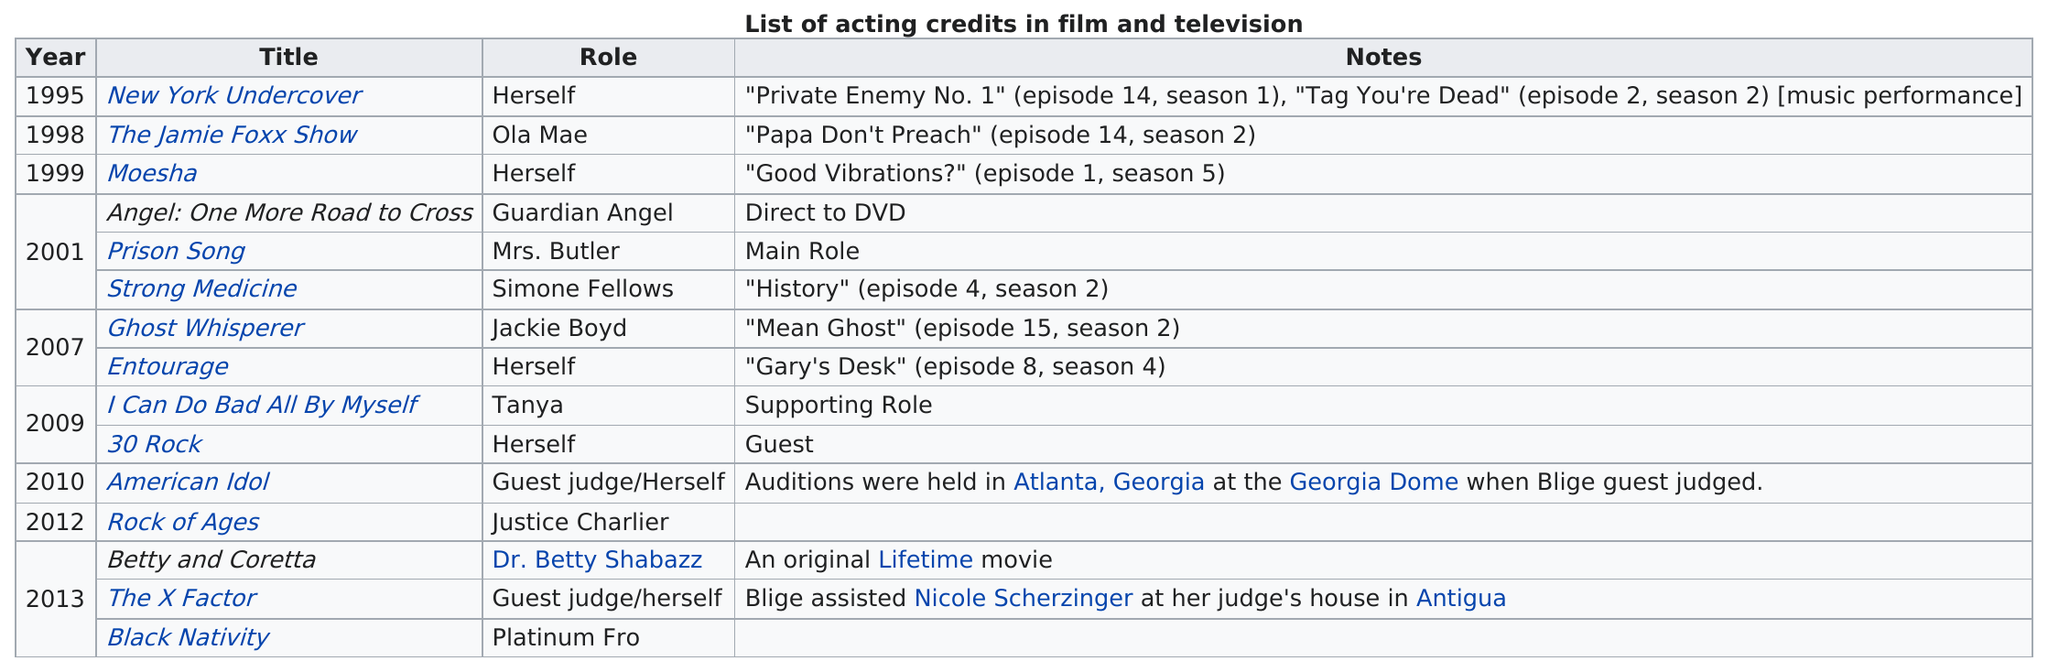Specify some key components in this picture. She has played herself six times. Since her role as Mrs. Butler, Mary J. Blige has played characters other than herself six times. 